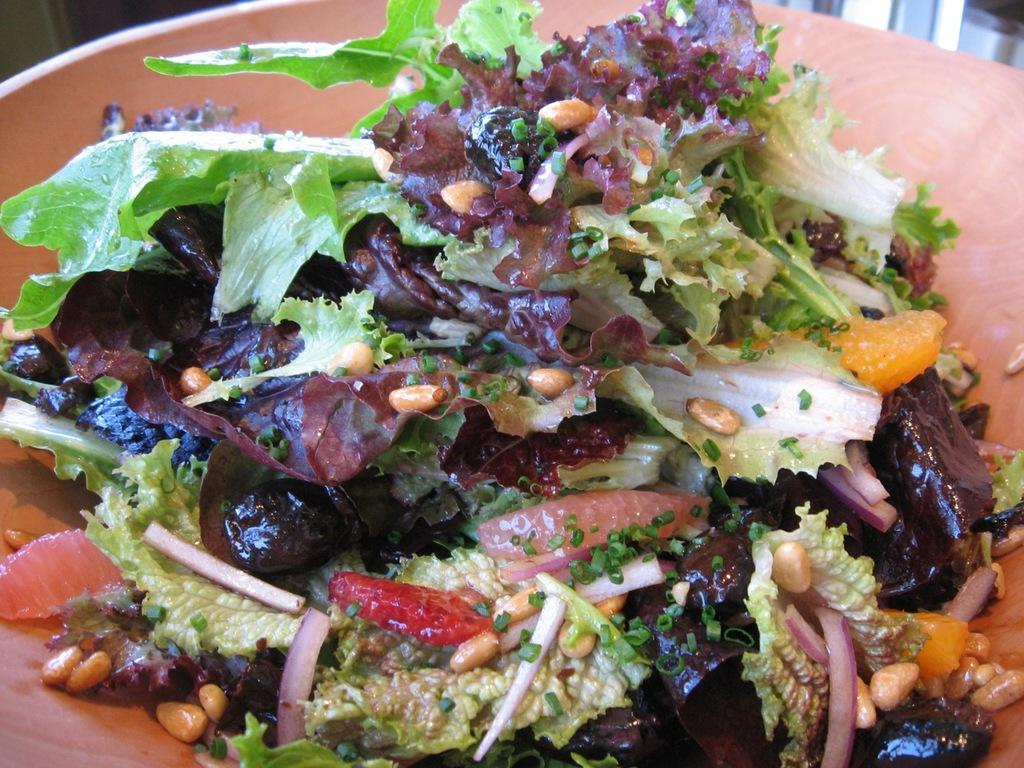What is the main subject of the image? There is a food item in the image. How is the food item presented in the image? The food item is in a plate. What type of crib is visible in the image? There is no crib present in the image; it only features a food item in a plate. How many dolls can be seen playing with the food item in the image? There are no dolls present in the image, and the food item is not being played with. 